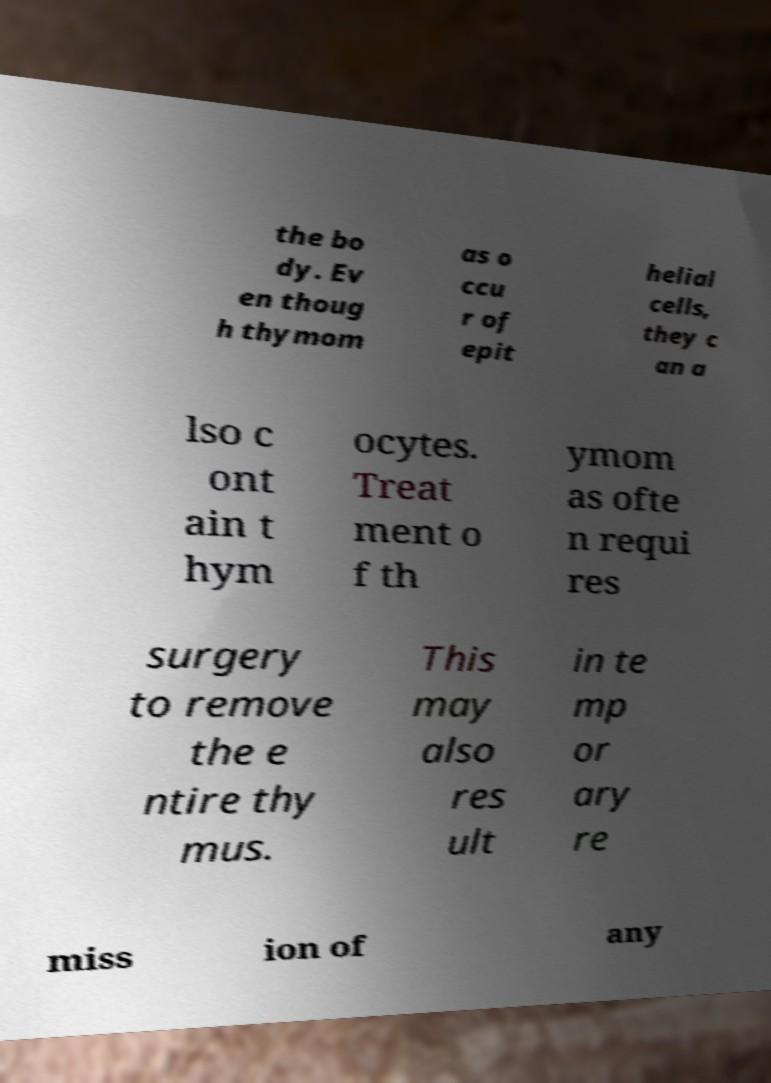Can you read and provide the text displayed in the image?This photo seems to have some interesting text. Can you extract and type it out for me? the bo dy. Ev en thoug h thymom as o ccu r of epit helial cells, they c an a lso c ont ain t hym ocytes. Treat ment o f th ymom as ofte n requi res surgery to remove the e ntire thy mus. This may also res ult in te mp or ary re miss ion of any 